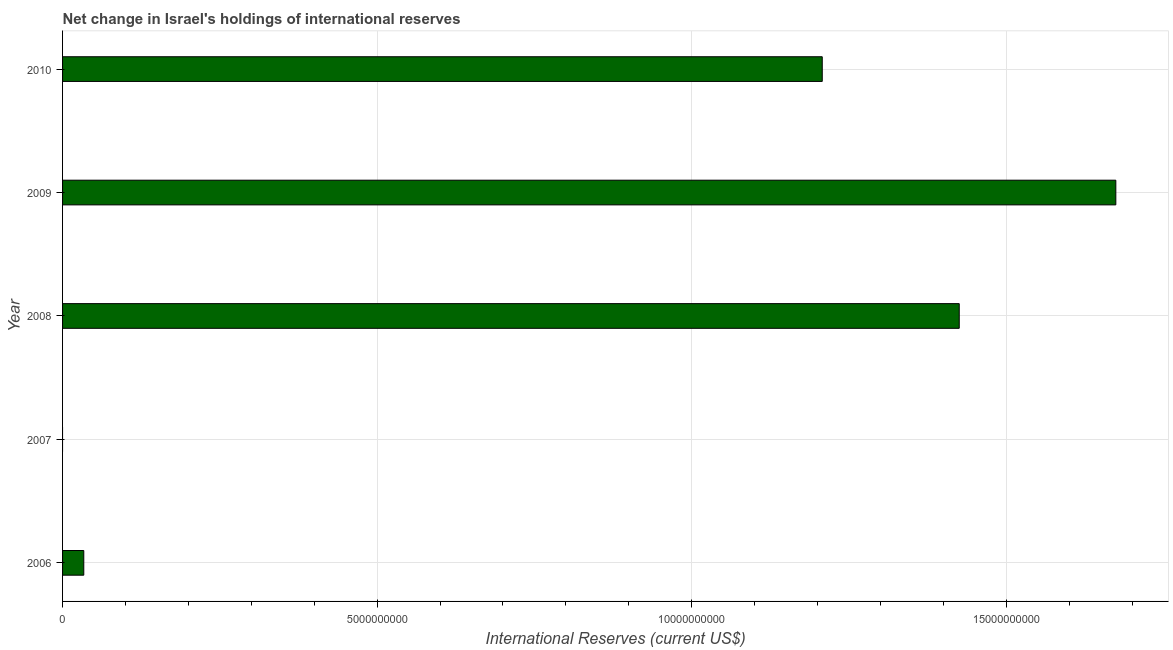Does the graph contain any zero values?
Your response must be concise. Yes. What is the title of the graph?
Offer a terse response. Net change in Israel's holdings of international reserves. What is the label or title of the X-axis?
Provide a short and direct response. International Reserves (current US$). What is the reserves and related items in 2006?
Provide a succinct answer. 3.37e+08. Across all years, what is the maximum reserves and related items?
Your answer should be compact. 1.67e+1. Across all years, what is the minimum reserves and related items?
Offer a terse response. 0. In which year was the reserves and related items maximum?
Your answer should be compact. 2009. What is the sum of the reserves and related items?
Your answer should be very brief. 4.34e+1. What is the difference between the reserves and related items in 2009 and 2010?
Make the answer very short. 4.67e+09. What is the average reserves and related items per year?
Offer a terse response. 8.68e+09. What is the median reserves and related items?
Provide a succinct answer. 1.21e+1. In how many years, is the reserves and related items greater than 12000000000 US$?
Give a very brief answer. 3. What is the difference between the highest and the second highest reserves and related items?
Ensure brevity in your answer.  2.49e+09. Is the sum of the reserves and related items in 2006 and 2008 greater than the maximum reserves and related items across all years?
Your answer should be compact. No. What is the difference between the highest and the lowest reserves and related items?
Offer a terse response. 1.67e+1. Are all the bars in the graph horizontal?
Give a very brief answer. Yes. What is the difference between two consecutive major ticks on the X-axis?
Keep it short and to the point. 5.00e+09. Are the values on the major ticks of X-axis written in scientific E-notation?
Provide a short and direct response. No. What is the International Reserves (current US$) of 2006?
Your answer should be compact. 3.37e+08. What is the International Reserves (current US$) of 2007?
Give a very brief answer. 0. What is the International Reserves (current US$) in 2008?
Give a very brief answer. 1.43e+1. What is the International Reserves (current US$) in 2009?
Keep it short and to the point. 1.67e+1. What is the International Reserves (current US$) in 2010?
Offer a terse response. 1.21e+1. What is the difference between the International Reserves (current US$) in 2006 and 2008?
Keep it short and to the point. -1.39e+1. What is the difference between the International Reserves (current US$) in 2006 and 2009?
Your response must be concise. -1.64e+1. What is the difference between the International Reserves (current US$) in 2006 and 2010?
Provide a succinct answer. -1.17e+1. What is the difference between the International Reserves (current US$) in 2008 and 2009?
Offer a very short reply. -2.49e+09. What is the difference between the International Reserves (current US$) in 2008 and 2010?
Provide a short and direct response. 2.18e+09. What is the difference between the International Reserves (current US$) in 2009 and 2010?
Your response must be concise. 4.67e+09. What is the ratio of the International Reserves (current US$) in 2006 to that in 2008?
Your response must be concise. 0.02. What is the ratio of the International Reserves (current US$) in 2006 to that in 2009?
Your answer should be compact. 0.02. What is the ratio of the International Reserves (current US$) in 2006 to that in 2010?
Provide a succinct answer. 0.03. What is the ratio of the International Reserves (current US$) in 2008 to that in 2009?
Offer a very short reply. 0.85. What is the ratio of the International Reserves (current US$) in 2008 to that in 2010?
Offer a terse response. 1.18. What is the ratio of the International Reserves (current US$) in 2009 to that in 2010?
Your response must be concise. 1.39. 